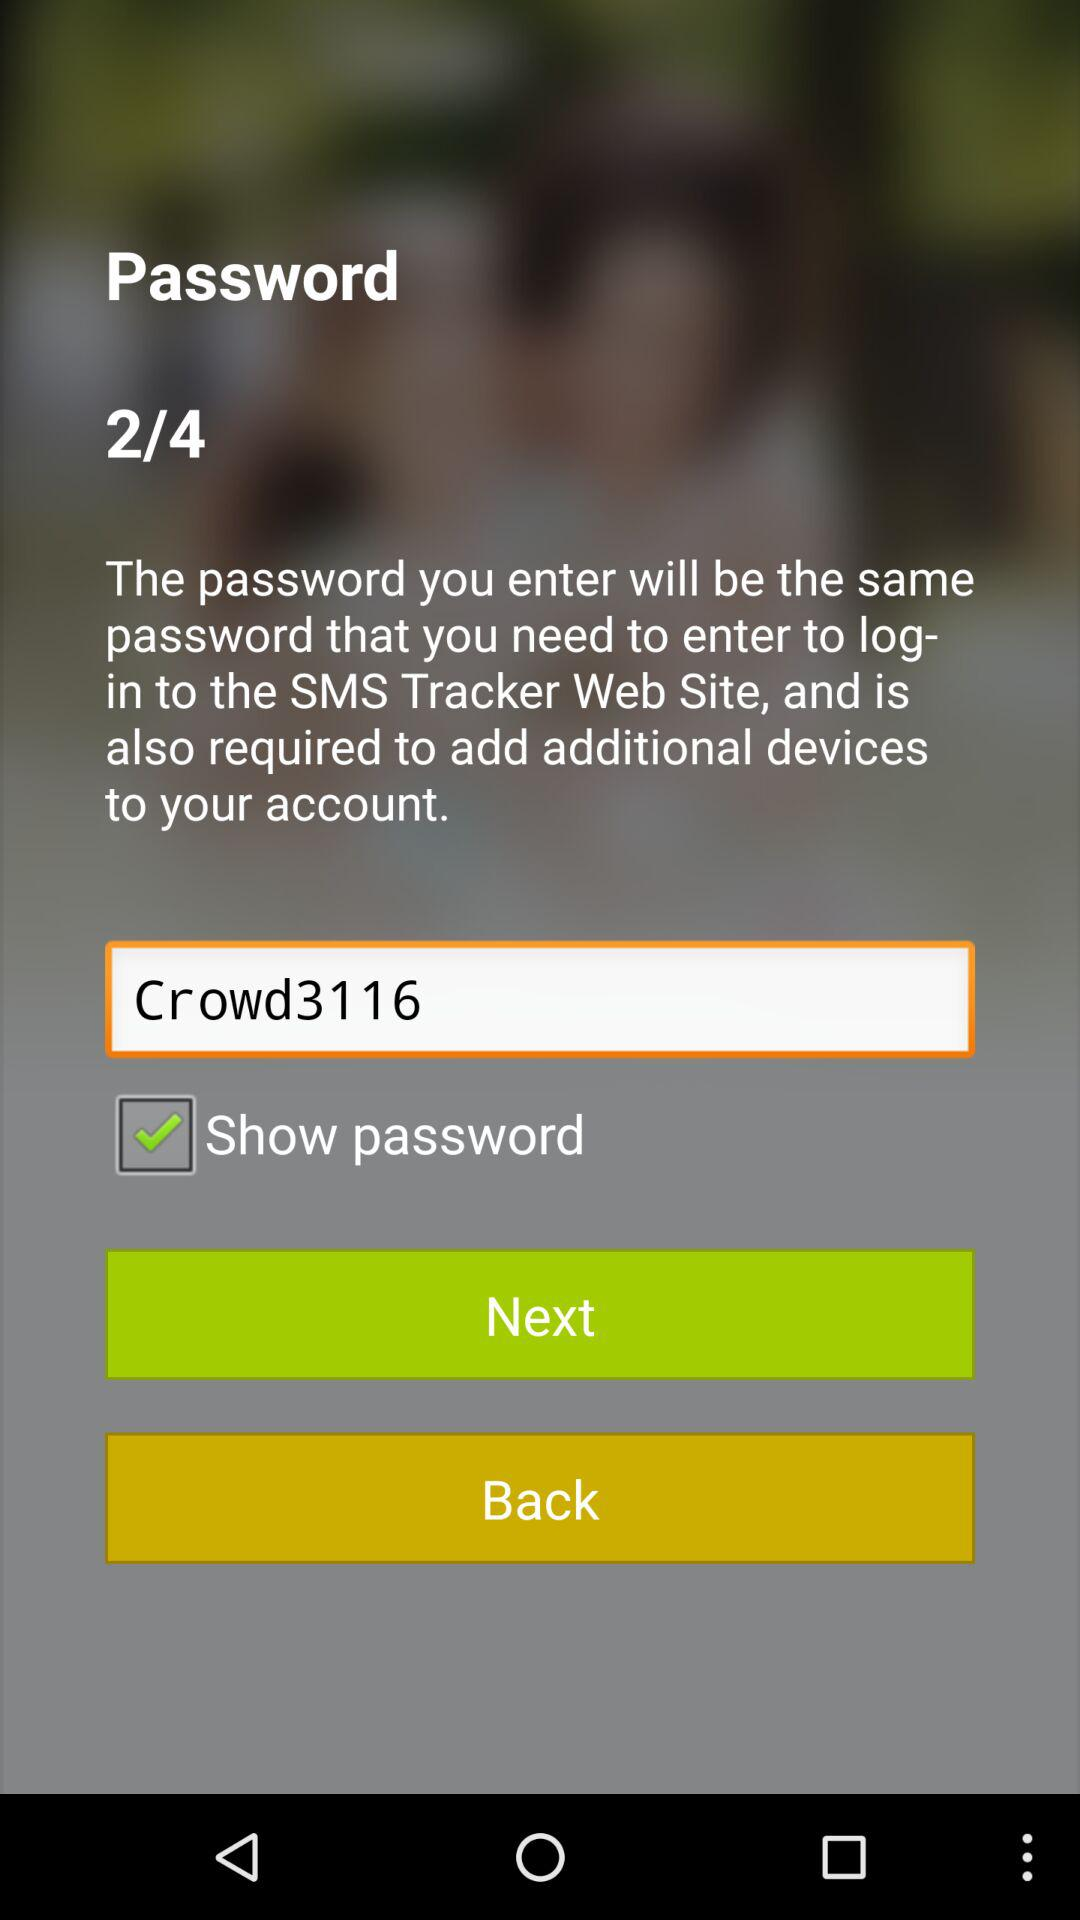What is the status of "Show password"? The status is "on". 